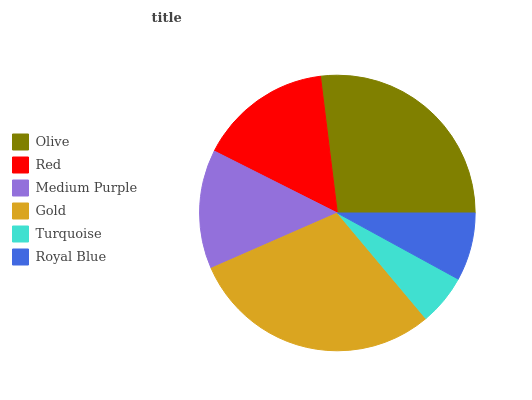Is Turquoise the minimum?
Answer yes or no. Yes. Is Gold the maximum?
Answer yes or no. Yes. Is Red the minimum?
Answer yes or no. No. Is Red the maximum?
Answer yes or no. No. Is Olive greater than Red?
Answer yes or no. Yes. Is Red less than Olive?
Answer yes or no. Yes. Is Red greater than Olive?
Answer yes or no. No. Is Olive less than Red?
Answer yes or no. No. Is Red the high median?
Answer yes or no. Yes. Is Medium Purple the low median?
Answer yes or no. Yes. Is Medium Purple the high median?
Answer yes or no. No. Is Turquoise the low median?
Answer yes or no. No. 